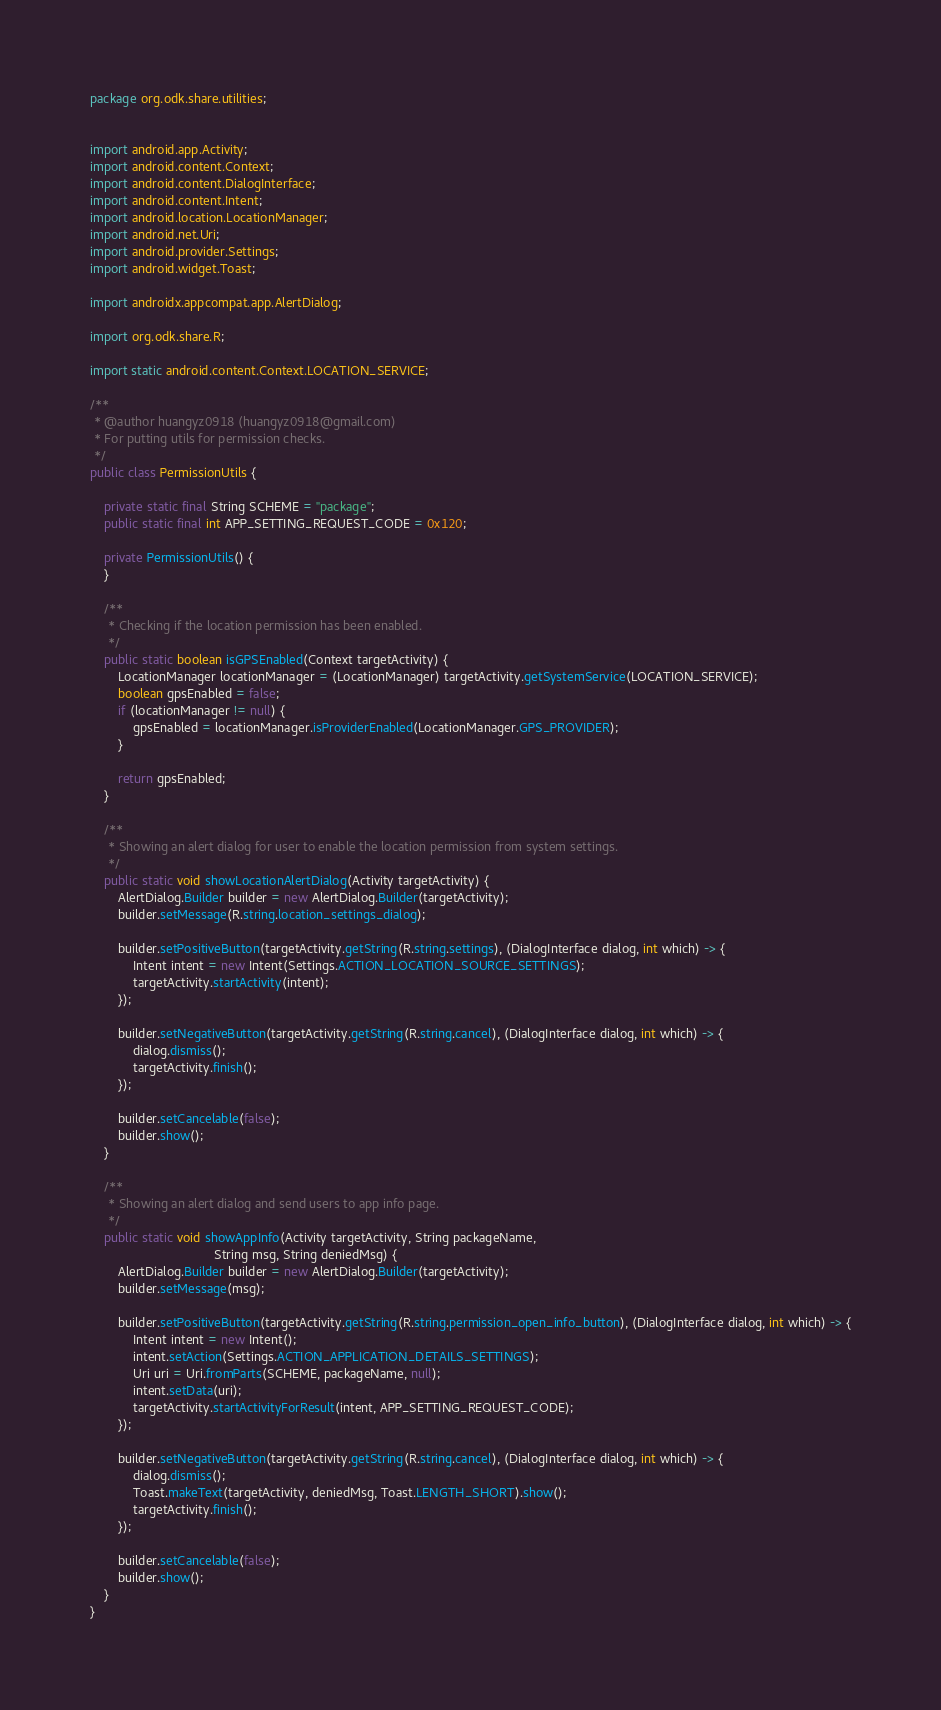<code> <loc_0><loc_0><loc_500><loc_500><_Java_>package org.odk.share.utilities;


import android.app.Activity;
import android.content.Context;
import android.content.DialogInterface;
import android.content.Intent;
import android.location.LocationManager;
import android.net.Uri;
import android.provider.Settings;
import android.widget.Toast;

import androidx.appcompat.app.AlertDialog;

import org.odk.share.R;

import static android.content.Context.LOCATION_SERVICE;

/**
 * @author huangyz0918 (huangyz0918@gmail.com)
 * For putting utils for permission checks.
 */
public class PermissionUtils {

    private static final String SCHEME = "package";
    public static final int APP_SETTING_REQUEST_CODE = 0x120;

    private PermissionUtils() {
    }

    /**
     * Checking if the location permission has been enabled.
     */
    public static boolean isGPSEnabled(Context targetActivity) {
        LocationManager locationManager = (LocationManager) targetActivity.getSystemService(LOCATION_SERVICE);
        boolean gpsEnabled = false;
        if (locationManager != null) {
            gpsEnabled = locationManager.isProviderEnabled(LocationManager.GPS_PROVIDER);
        }

        return gpsEnabled;
    }

    /**
     * Showing an alert dialog for user to enable the location permission from system settings.
     */
    public static void showLocationAlertDialog(Activity targetActivity) {
        AlertDialog.Builder builder = new AlertDialog.Builder(targetActivity);
        builder.setMessage(R.string.location_settings_dialog);

        builder.setPositiveButton(targetActivity.getString(R.string.settings), (DialogInterface dialog, int which) -> {
            Intent intent = new Intent(Settings.ACTION_LOCATION_SOURCE_SETTINGS);
            targetActivity.startActivity(intent);
        });

        builder.setNegativeButton(targetActivity.getString(R.string.cancel), (DialogInterface dialog, int which) -> {
            dialog.dismiss();
            targetActivity.finish();
        });

        builder.setCancelable(false);
        builder.show();
    }

    /**
     * Showing an alert dialog and send users to app info page.
     */
    public static void showAppInfo(Activity targetActivity, String packageName,
                                   String msg, String deniedMsg) {
        AlertDialog.Builder builder = new AlertDialog.Builder(targetActivity);
        builder.setMessage(msg);

        builder.setPositiveButton(targetActivity.getString(R.string.permission_open_info_button), (DialogInterface dialog, int which) -> {
            Intent intent = new Intent();
            intent.setAction(Settings.ACTION_APPLICATION_DETAILS_SETTINGS);
            Uri uri = Uri.fromParts(SCHEME, packageName, null);
            intent.setData(uri);
            targetActivity.startActivityForResult(intent, APP_SETTING_REQUEST_CODE);
        });

        builder.setNegativeButton(targetActivity.getString(R.string.cancel), (DialogInterface dialog, int which) -> {
            dialog.dismiss();
            Toast.makeText(targetActivity, deniedMsg, Toast.LENGTH_SHORT).show();
            targetActivity.finish();
        });

        builder.setCancelable(false);
        builder.show();
    }
}


</code> 